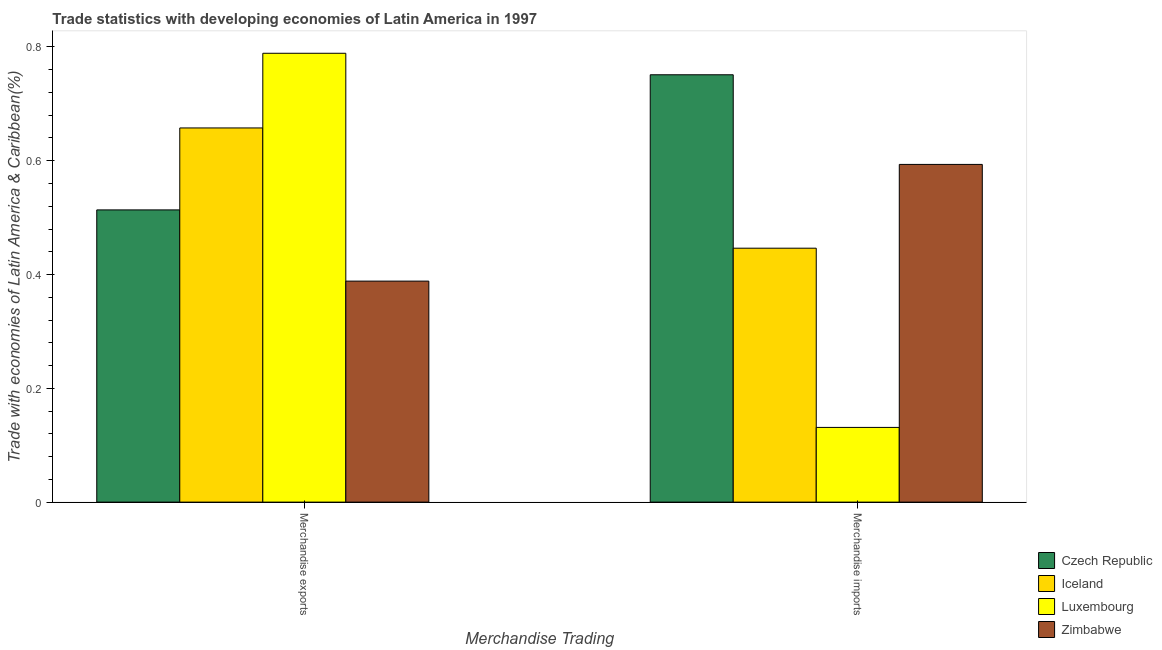How many different coloured bars are there?
Offer a terse response. 4. Are the number of bars per tick equal to the number of legend labels?
Your response must be concise. Yes. How many bars are there on the 1st tick from the right?
Your answer should be compact. 4. What is the merchandise imports in Iceland?
Offer a very short reply. 0.45. Across all countries, what is the maximum merchandise imports?
Provide a short and direct response. 0.75. Across all countries, what is the minimum merchandise exports?
Ensure brevity in your answer.  0.39. In which country was the merchandise imports maximum?
Provide a succinct answer. Czech Republic. In which country was the merchandise imports minimum?
Give a very brief answer. Luxembourg. What is the total merchandise imports in the graph?
Offer a terse response. 1.92. What is the difference between the merchandise exports in Iceland and that in Zimbabwe?
Keep it short and to the point. 0.27. What is the difference between the merchandise exports in Iceland and the merchandise imports in Czech Republic?
Offer a terse response. -0.09. What is the average merchandise imports per country?
Your answer should be very brief. 0.48. What is the difference between the merchandise imports and merchandise exports in Zimbabwe?
Provide a succinct answer. 0.21. In how many countries, is the merchandise imports greater than 0.48000000000000004 %?
Your response must be concise. 2. What is the ratio of the merchandise imports in Czech Republic to that in Zimbabwe?
Give a very brief answer. 1.27. In how many countries, is the merchandise exports greater than the average merchandise exports taken over all countries?
Ensure brevity in your answer.  2. What does the 3rd bar from the left in Merchandise imports represents?
Your answer should be very brief. Luxembourg. What does the 4th bar from the right in Merchandise imports represents?
Keep it short and to the point. Czech Republic. Are all the bars in the graph horizontal?
Your answer should be very brief. No. How many countries are there in the graph?
Offer a very short reply. 4. Are the values on the major ticks of Y-axis written in scientific E-notation?
Offer a terse response. No. Does the graph contain any zero values?
Your answer should be compact. No. Where does the legend appear in the graph?
Your response must be concise. Bottom right. How are the legend labels stacked?
Your response must be concise. Vertical. What is the title of the graph?
Provide a short and direct response. Trade statistics with developing economies of Latin America in 1997. Does "Benin" appear as one of the legend labels in the graph?
Make the answer very short. No. What is the label or title of the X-axis?
Provide a short and direct response. Merchandise Trading. What is the label or title of the Y-axis?
Provide a succinct answer. Trade with economies of Latin America & Caribbean(%). What is the Trade with economies of Latin America & Caribbean(%) of Czech Republic in Merchandise exports?
Provide a short and direct response. 0.51. What is the Trade with economies of Latin America & Caribbean(%) of Iceland in Merchandise exports?
Your answer should be very brief. 0.66. What is the Trade with economies of Latin America & Caribbean(%) in Luxembourg in Merchandise exports?
Make the answer very short. 0.79. What is the Trade with economies of Latin America & Caribbean(%) in Zimbabwe in Merchandise exports?
Your response must be concise. 0.39. What is the Trade with economies of Latin America & Caribbean(%) of Czech Republic in Merchandise imports?
Provide a short and direct response. 0.75. What is the Trade with economies of Latin America & Caribbean(%) in Iceland in Merchandise imports?
Offer a very short reply. 0.45. What is the Trade with economies of Latin America & Caribbean(%) of Luxembourg in Merchandise imports?
Provide a short and direct response. 0.13. What is the Trade with economies of Latin America & Caribbean(%) in Zimbabwe in Merchandise imports?
Ensure brevity in your answer.  0.59. Across all Merchandise Trading, what is the maximum Trade with economies of Latin America & Caribbean(%) of Czech Republic?
Provide a succinct answer. 0.75. Across all Merchandise Trading, what is the maximum Trade with economies of Latin America & Caribbean(%) in Iceland?
Give a very brief answer. 0.66. Across all Merchandise Trading, what is the maximum Trade with economies of Latin America & Caribbean(%) of Luxembourg?
Offer a terse response. 0.79. Across all Merchandise Trading, what is the maximum Trade with economies of Latin America & Caribbean(%) of Zimbabwe?
Offer a very short reply. 0.59. Across all Merchandise Trading, what is the minimum Trade with economies of Latin America & Caribbean(%) in Czech Republic?
Your answer should be very brief. 0.51. Across all Merchandise Trading, what is the minimum Trade with economies of Latin America & Caribbean(%) of Iceland?
Offer a terse response. 0.45. Across all Merchandise Trading, what is the minimum Trade with economies of Latin America & Caribbean(%) in Luxembourg?
Keep it short and to the point. 0.13. Across all Merchandise Trading, what is the minimum Trade with economies of Latin America & Caribbean(%) of Zimbabwe?
Offer a very short reply. 0.39. What is the total Trade with economies of Latin America & Caribbean(%) of Czech Republic in the graph?
Offer a terse response. 1.26. What is the total Trade with economies of Latin America & Caribbean(%) of Iceland in the graph?
Ensure brevity in your answer.  1.1. What is the total Trade with economies of Latin America & Caribbean(%) of Luxembourg in the graph?
Provide a short and direct response. 0.92. What is the difference between the Trade with economies of Latin America & Caribbean(%) in Czech Republic in Merchandise exports and that in Merchandise imports?
Provide a succinct answer. -0.24. What is the difference between the Trade with economies of Latin America & Caribbean(%) of Iceland in Merchandise exports and that in Merchandise imports?
Offer a terse response. 0.21. What is the difference between the Trade with economies of Latin America & Caribbean(%) of Luxembourg in Merchandise exports and that in Merchandise imports?
Give a very brief answer. 0.66. What is the difference between the Trade with economies of Latin America & Caribbean(%) in Zimbabwe in Merchandise exports and that in Merchandise imports?
Offer a very short reply. -0.21. What is the difference between the Trade with economies of Latin America & Caribbean(%) of Czech Republic in Merchandise exports and the Trade with economies of Latin America & Caribbean(%) of Iceland in Merchandise imports?
Keep it short and to the point. 0.07. What is the difference between the Trade with economies of Latin America & Caribbean(%) in Czech Republic in Merchandise exports and the Trade with economies of Latin America & Caribbean(%) in Luxembourg in Merchandise imports?
Your answer should be compact. 0.38. What is the difference between the Trade with economies of Latin America & Caribbean(%) of Czech Republic in Merchandise exports and the Trade with economies of Latin America & Caribbean(%) of Zimbabwe in Merchandise imports?
Give a very brief answer. -0.08. What is the difference between the Trade with economies of Latin America & Caribbean(%) in Iceland in Merchandise exports and the Trade with economies of Latin America & Caribbean(%) in Luxembourg in Merchandise imports?
Offer a very short reply. 0.53. What is the difference between the Trade with economies of Latin America & Caribbean(%) in Iceland in Merchandise exports and the Trade with economies of Latin America & Caribbean(%) in Zimbabwe in Merchandise imports?
Your response must be concise. 0.06. What is the difference between the Trade with economies of Latin America & Caribbean(%) in Luxembourg in Merchandise exports and the Trade with economies of Latin America & Caribbean(%) in Zimbabwe in Merchandise imports?
Provide a succinct answer. 0.2. What is the average Trade with economies of Latin America & Caribbean(%) in Czech Republic per Merchandise Trading?
Your answer should be very brief. 0.63. What is the average Trade with economies of Latin America & Caribbean(%) of Iceland per Merchandise Trading?
Offer a terse response. 0.55. What is the average Trade with economies of Latin America & Caribbean(%) of Luxembourg per Merchandise Trading?
Make the answer very short. 0.46. What is the average Trade with economies of Latin America & Caribbean(%) of Zimbabwe per Merchandise Trading?
Keep it short and to the point. 0.49. What is the difference between the Trade with economies of Latin America & Caribbean(%) of Czech Republic and Trade with economies of Latin America & Caribbean(%) of Iceland in Merchandise exports?
Ensure brevity in your answer.  -0.14. What is the difference between the Trade with economies of Latin America & Caribbean(%) of Czech Republic and Trade with economies of Latin America & Caribbean(%) of Luxembourg in Merchandise exports?
Keep it short and to the point. -0.28. What is the difference between the Trade with economies of Latin America & Caribbean(%) in Czech Republic and Trade with economies of Latin America & Caribbean(%) in Zimbabwe in Merchandise exports?
Make the answer very short. 0.13. What is the difference between the Trade with economies of Latin America & Caribbean(%) in Iceland and Trade with economies of Latin America & Caribbean(%) in Luxembourg in Merchandise exports?
Your response must be concise. -0.13. What is the difference between the Trade with economies of Latin America & Caribbean(%) in Iceland and Trade with economies of Latin America & Caribbean(%) in Zimbabwe in Merchandise exports?
Offer a terse response. 0.27. What is the difference between the Trade with economies of Latin America & Caribbean(%) of Luxembourg and Trade with economies of Latin America & Caribbean(%) of Zimbabwe in Merchandise exports?
Offer a terse response. 0.4. What is the difference between the Trade with economies of Latin America & Caribbean(%) of Czech Republic and Trade with economies of Latin America & Caribbean(%) of Iceland in Merchandise imports?
Make the answer very short. 0.3. What is the difference between the Trade with economies of Latin America & Caribbean(%) in Czech Republic and Trade with economies of Latin America & Caribbean(%) in Luxembourg in Merchandise imports?
Give a very brief answer. 0.62. What is the difference between the Trade with economies of Latin America & Caribbean(%) in Czech Republic and Trade with economies of Latin America & Caribbean(%) in Zimbabwe in Merchandise imports?
Make the answer very short. 0.16. What is the difference between the Trade with economies of Latin America & Caribbean(%) of Iceland and Trade with economies of Latin America & Caribbean(%) of Luxembourg in Merchandise imports?
Keep it short and to the point. 0.32. What is the difference between the Trade with economies of Latin America & Caribbean(%) in Iceland and Trade with economies of Latin America & Caribbean(%) in Zimbabwe in Merchandise imports?
Your answer should be compact. -0.15. What is the difference between the Trade with economies of Latin America & Caribbean(%) in Luxembourg and Trade with economies of Latin America & Caribbean(%) in Zimbabwe in Merchandise imports?
Your response must be concise. -0.46. What is the ratio of the Trade with economies of Latin America & Caribbean(%) of Czech Republic in Merchandise exports to that in Merchandise imports?
Give a very brief answer. 0.68. What is the ratio of the Trade with economies of Latin America & Caribbean(%) in Iceland in Merchandise exports to that in Merchandise imports?
Ensure brevity in your answer.  1.47. What is the ratio of the Trade with economies of Latin America & Caribbean(%) in Luxembourg in Merchandise exports to that in Merchandise imports?
Provide a succinct answer. 6.01. What is the ratio of the Trade with economies of Latin America & Caribbean(%) of Zimbabwe in Merchandise exports to that in Merchandise imports?
Offer a terse response. 0.65. What is the difference between the highest and the second highest Trade with economies of Latin America & Caribbean(%) of Czech Republic?
Provide a succinct answer. 0.24. What is the difference between the highest and the second highest Trade with economies of Latin America & Caribbean(%) of Iceland?
Give a very brief answer. 0.21. What is the difference between the highest and the second highest Trade with economies of Latin America & Caribbean(%) in Luxembourg?
Make the answer very short. 0.66. What is the difference between the highest and the second highest Trade with economies of Latin America & Caribbean(%) in Zimbabwe?
Provide a succinct answer. 0.21. What is the difference between the highest and the lowest Trade with economies of Latin America & Caribbean(%) in Czech Republic?
Keep it short and to the point. 0.24. What is the difference between the highest and the lowest Trade with economies of Latin America & Caribbean(%) of Iceland?
Ensure brevity in your answer.  0.21. What is the difference between the highest and the lowest Trade with economies of Latin America & Caribbean(%) in Luxembourg?
Give a very brief answer. 0.66. What is the difference between the highest and the lowest Trade with economies of Latin America & Caribbean(%) of Zimbabwe?
Keep it short and to the point. 0.21. 